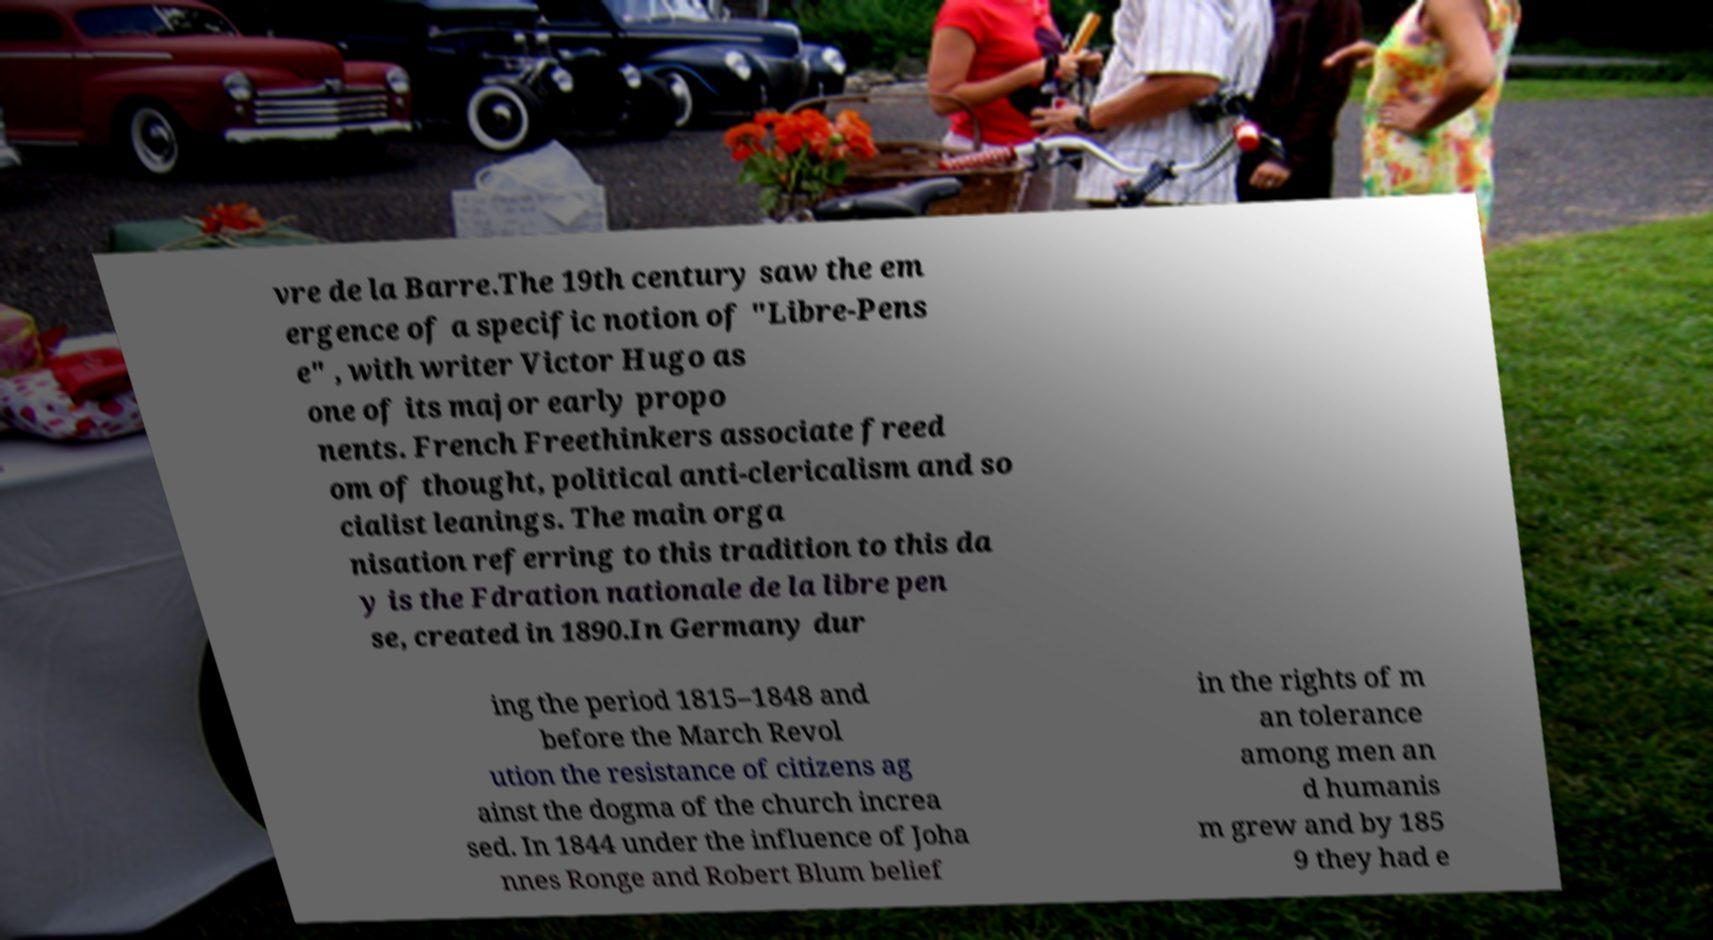What messages or text are displayed in this image? I need them in a readable, typed format. vre de la Barre.The 19th century saw the em ergence of a specific notion of "Libre-Pens e" , with writer Victor Hugo as one of its major early propo nents. French Freethinkers associate freed om of thought, political anti-clericalism and so cialist leanings. The main orga nisation referring to this tradition to this da y is the Fdration nationale de la libre pen se, created in 1890.In Germany dur ing the period 1815–1848 and before the March Revol ution the resistance of citizens ag ainst the dogma of the church increa sed. In 1844 under the influence of Joha nnes Ronge and Robert Blum belief in the rights of m an tolerance among men an d humanis m grew and by 185 9 they had e 